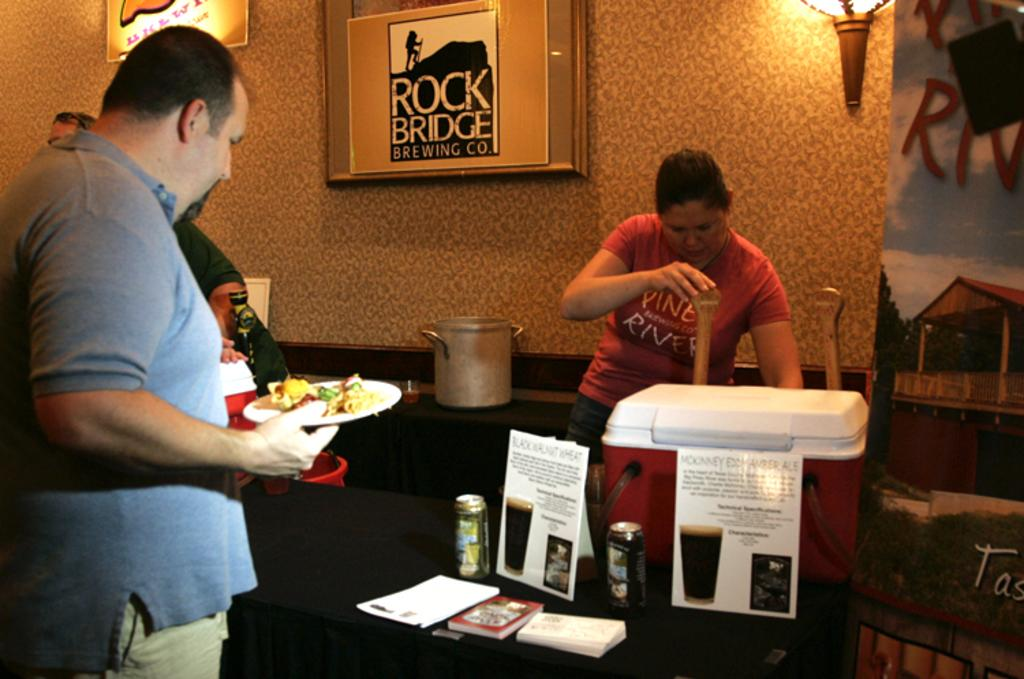<image>
Share a concise interpretation of the image provided. A man with a plate of food stands in front of a framed sign for Rock Bridge Brewing company. 